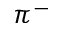Convert formula to latex. <formula><loc_0><loc_0><loc_500><loc_500>\pi ^ { - }</formula> 